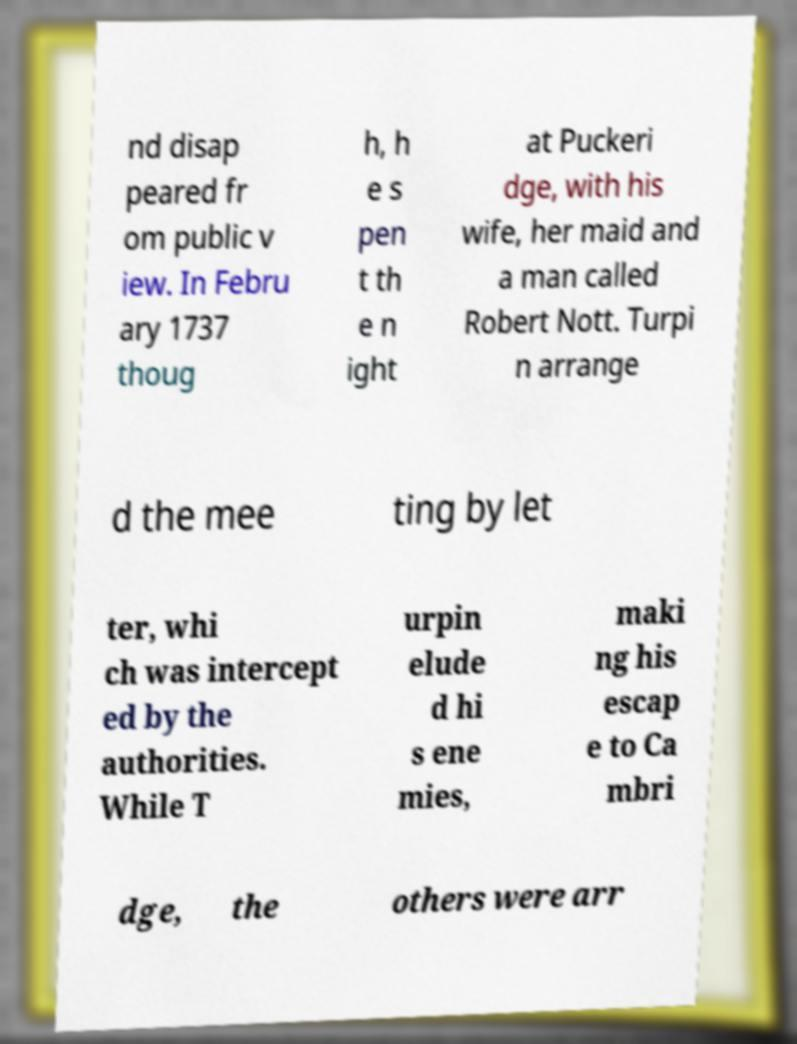Can you read and provide the text displayed in the image?This photo seems to have some interesting text. Can you extract and type it out for me? nd disap peared fr om public v iew. In Febru ary 1737 thoug h, h e s pen t th e n ight at Puckeri dge, with his wife, her maid and a man called Robert Nott. Turpi n arrange d the mee ting by let ter, whi ch was intercept ed by the authorities. While T urpin elude d hi s ene mies, maki ng his escap e to Ca mbri dge, the others were arr 